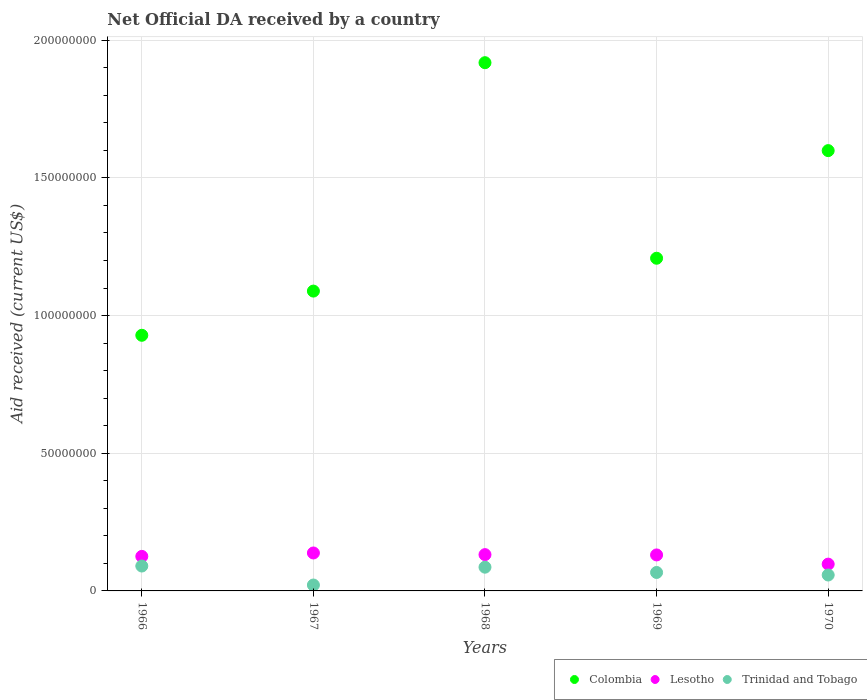What is the net official development assistance aid received in Trinidad and Tobago in 1968?
Your response must be concise. 8.62e+06. Across all years, what is the maximum net official development assistance aid received in Trinidad and Tobago?
Offer a terse response. 9.04e+06. Across all years, what is the minimum net official development assistance aid received in Lesotho?
Your answer should be compact. 9.73e+06. In which year was the net official development assistance aid received in Colombia maximum?
Give a very brief answer. 1968. What is the total net official development assistance aid received in Colombia in the graph?
Give a very brief answer. 6.74e+08. What is the difference between the net official development assistance aid received in Colombia in 1967 and that in 1968?
Give a very brief answer. -8.29e+07. What is the difference between the net official development assistance aid received in Trinidad and Tobago in 1969 and the net official development assistance aid received in Lesotho in 1970?
Ensure brevity in your answer.  -3.03e+06. What is the average net official development assistance aid received in Trinidad and Tobago per year?
Give a very brief answer. 6.46e+06. In the year 1970, what is the difference between the net official development assistance aid received in Colombia and net official development assistance aid received in Lesotho?
Your answer should be very brief. 1.50e+08. What is the ratio of the net official development assistance aid received in Lesotho in 1966 to that in 1970?
Your answer should be compact. 1.29. Is the net official development assistance aid received in Trinidad and Tobago in 1967 less than that in 1970?
Provide a succinct answer. Yes. What is the difference between the highest and the second highest net official development assistance aid received in Trinidad and Tobago?
Ensure brevity in your answer.  4.20e+05. What is the difference between the highest and the lowest net official development assistance aid received in Lesotho?
Your answer should be compact. 4.05e+06. Is the sum of the net official development assistance aid received in Colombia in 1966 and 1970 greater than the maximum net official development assistance aid received in Lesotho across all years?
Give a very brief answer. Yes. Is the net official development assistance aid received in Trinidad and Tobago strictly greater than the net official development assistance aid received in Colombia over the years?
Give a very brief answer. No. How many years are there in the graph?
Give a very brief answer. 5. What is the difference between two consecutive major ticks on the Y-axis?
Your answer should be very brief. 5.00e+07. Does the graph contain any zero values?
Make the answer very short. No. Where does the legend appear in the graph?
Provide a succinct answer. Bottom right. How many legend labels are there?
Give a very brief answer. 3. What is the title of the graph?
Your response must be concise. Net Official DA received by a country. Does "Central Europe" appear as one of the legend labels in the graph?
Offer a very short reply. No. What is the label or title of the X-axis?
Ensure brevity in your answer.  Years. What is the label or title of the Y-axis?
Your answer should be very brief. Aid received (current US$). What is the Aid received (current US$) of Colombia in 1966?
Offer a terse response. 9.28e+07. What is the Aid received (current US$) of Lesotho in 1966?
Provide a short and direct response. 1.25e+07. What is the Aid received (current US$) of Trinidad and Tobago in 1966?
Offer a very short reply. 9.04e+06. What is the Aid received (current US$) of Colombia in 1967?
Your response must be concise. 1.09e+08. What is the Aid received (current US$) of Lesotho in 1967?
Provide a short and direct response. 1.38e+07. What is the Aid received (current US$) of Trinidad and Tobago in 1967?
Make the answer very short. 2.14e+06. What is the Aid received (current US$) of Colombia in 1968?
Ensure brevity in your answer.  1.92e+08. What is the Aid received (current US$) of Lesotho in 1968?
Make the answer very short. 1.32e+07. What is the Aid received (current US$) of Trinidad and Tobago in 1968?
Ensure brevity in your answer.  8.62e+06. What is the Aid received (current US$) in Colombia in 1969?
Make the answer very short. 1.21e+08. What is the Aid received (current US$) of Lesotho in 1969?
Provide a short and direct response. 1.31e+07. What is the Aid received (current US$) in Trinidad and Tobago in 1969?
Your response must be concise. 6.70e+06. What is the Aid received (current US$) in Colombia in 1970?
Your answer should be compact. 1.60e+08. What is the Aid received (current US$) of Lesotho in 1970?
Your answer should be compact. 9.73e+06. What is the Aid received (current US$) of Trinidad and Tobago in 1970?
Give a very brief answer. 5.78e+06. Across all years, what is the maximum Aid received (current US$) of Colombia?
Your response must be concise. 1.92e+08. Across all years, what is the maximum Aid received (current US$) of Lesotho?
Your response must be concise. 1.38e+07. Across all years, what is the maximum Aid received (current US$) of Trinidad and Tobago?
Ensure brevity in your answer.  9.04e+06. Across all years, what is the minimum Aid received (current US$) of Colombia?
Make the answer very short. 9.28e+07. Across all years, what is the minimum Aid received (current US$) in Lesotho?
Offer a terse response. 9.73e+06. Across all years, what is the minimum Aid received (current US$) of Trinidad and Tobago?
Make the answer very short. 2.14e+06. What is the total Aid received (current US$) of Colombia in the graph?
Offer a terse response. 6.74e+08. What is the total Aid received (current US$) in Lesotho in the graph?
Keep it short and to the point. 6.23e+07. What is the total Aid received (current US$) of Trinidad and Tobago in the graph?
Offer a very short reply. 3.23e+07. What is the difference between the Aid received (current US$) in Colombia in 1966 and that in 1967?
Ensure brevity in your answer.  -1.60e+07. What is the difference between the Aid received (current US$) in Lesotho in 1966 and that in 1967?
Ensure brevity in your answer.  -1.24e+06. What is the difference between the Aid received (current US$) in Trinidad and Tobago in 1966 and that in 1967?
Offer a terse response. 6.90e+06. What is the difference between the Aid received (current US$) in Colombia in 1966 and that in 1968?
Ensure brevity in your answer.  -9.90e+07. What is the difference between the Aid received (current US$) of Lesotho in 1966 and that in 1968?
Keep it short and to the point. -6.40e+05. What is the difference between the Aid received (current US$) of Colombia in 1966 and that in 1969?
Give a very brief answer. -2.80e+07. What is the difference between the Aid received (current US$) in Lesotho in 1966 and that in 1969?
Your answer should be compact. -5.30e+05. What is the difference between the Aid received (current US$) of Trinidad and Tobago in 1966 and that in 1969?
Offer a very short reply. 2.34e+06. What is the difference between the Aid received (current US$) in Colombia in 1966 and that in 1970?
Provide a succinct answer. -6.71e+07. What is the difference between the Aid received (current US$) of Lesotho in 1966 and that in 1970?
Offer a very short reply. 2.81e+06. What is the difference between the Aid received (current US$) in Trinidad and Tobago in 1966 and that in 1970?
Keep it short and to the point. 3.26e+06. What is the difference between the Aid received (current US$) of Colombia in 1967 and that in 1968?
Offer a terse response. -8.29e+07. What is the difference between the Aid received (current US$) of Trinidad and Tobago in 1967 and that in 1968?
Give a very brief answer. -6.48e+06. What is the difference between the Aid received (current US$) of Colombia in 1967 and that in 1969?
Ensure brevity in your answer.  -1.19e+07. What is the difference between the Aid received (current US$) in Lesotho in 1967 and that in 1969?
Your answer should be very brief. 7.10e+05. What is the difference between the Aid received (current US$) of Trinidad and Tobago in 1967 and that in 1969?
Provide a short and direct response. -4.56e+06. What is the difference between the Aid received (current US$) in Colombia in 1967 and that in 1970?
Provide a succinct answer. -5.10e+07. What is the difference between the Aid received (current US$) of Lesotho in 1967 and that in 1970?
Give a very brief answer. 4.05e+06. What is the difference between the Aid received (current US$) of Trinidad and Tobago in 1967 and that in 1970?
Your answer should be very brief. -3.64e+06. What is the difference between the Aid received (current US$) in Colombia in 1968 and that in 1969?
Provide a succinct answer. 7.10e+07. What is the difference between the Aid received (current US$) in Trinidad and Tobago in 1968 and that in 1969?
Give a very brief answer. 1.92e+06. What is the difference between the Aid received (current US$) in Colombia in 1968 and that in 1970?
Ensure brevity in your answer.  3.19e+07. What is the difference between the Aid received (current US$) of Lesotho in 1968 and that in 1970?
Keep it short and to the point. 3.45e+06. What is the difference between the Aid received (current US$) in Trinidad and Tobago in 1968 and that in 1970?
Your response must be concise. 2.84e+06. What is the difference between the Aid received (current US$) of Colombia in 1969 and that in 1970?
Your answer should be very brief. -3.91e+07. What is the difference between the Aid received (current US$) in Lesotho in 1969 and that in 1970?
Make the answer very short. 3.34e+06. What is the difference between the Aid received (current US$) in Trinidad and Tobago in 1969 and that in 1970?
Give a very brief answer. 9.20e+05. What is the difference between the Aid received (current US$) of Colombia in 1966 and the Aid received (current US$) of Lesotho in 1967?
Keep it short and to the point. 7.90e+07. What is the difference between the Aid received (current US$) in Colombia in 1966 and the Aid received (current US$) in Trinidad and Tobago in 1967?
Provide a short and direct response. 9.07e+07. What is the difference between the Aid received (current US$) of Lesotho in 1966 and the Aid received (current US$) of Trinidad and Tobago in 1967?
Offer a very short reply. 1.04e+07. What is the difference between the Aid received (current US$) of Colombia in 1966 and the Aid received (current US$) of Lesotho in 1968?
Give a very brief answer. 7.96e+07. What is the difference between the Aid received (current US$) in Colombia in 1966 and the Aid received (current US$) in Trinidad and Tobago in 1968?
Ensure brevity in your answer.  8.42e+07. What is the difference between the Aid received (current US$) in Lesotho in 1966 and the Aid received (current US$) in Trinidad and Tobago in 1968?
Your answer should be very brief. 3.92e+06. What is the difference between the Aid received (current US$) in Colombia in 1966 and the Aid received (current US$) in Lesotho in 1969?
Offer a terse response. 7.98e+07. What is the difference between the Aid received (current US$) in Colombia in 1966 and the Aid received (current US$) in Trinidad and Tobago in 1969?
Your response must be concise. 8.61e+07. What is the difference between the Aid received (current US$) of Lesotho in 1966 and the Aid received (current US$) of Trinidad and Tobago in 1969?
Keep it short and to the point. 5.84e+06. What is the difference between the Aid received (current US$) of Colombia in 1966 and the Aid received (current US$) of Lesotho in 1970?
Provide a succinct answer. 8.31e+07. What is the difference between the Aid received (current US$) of Colombia in 1966 and the Aid received (current US$) of Trinidad and Tobago in 1970?
Offer a very short reply. 8.70e+07. What is the difference between the Aid received (current US$) in Lesotho in 1966 and the Aid received (current US$) in Trinidad and Tobago in 1970?
Your answer should be very brief. 6.76e+06. What is the difference between the Aid received (current US$) of Colombia in 1967 and the Aid received (current US$) of Lesotho in 1968?
Provide a succinct answer. 9.57e+07. What is the difference between the Aid received (current US$) of Colombia in 1967 and the Aid received (current US$) of Trinidad and Tobago in 1968?
Ensure brevity in your answer.  1.00e+08. What is the difference between the Aid received (current US$) of Lesotho in 1967 and the Aid received (current US$) of Trinidad and Tobago in 1968?
Provide a short and direct response. 5.16e+06. What is the difference between the Aid received (current US$) in Colombia in 1967 and the Aid received (current US$) in Lesotho in 1969?
Ensure brevity in your answer.  9.58e+07. What is the difference between the Aid received (current US$) of Colombia in 1967 and the Aid received (current US$) of Trinidad and Tobago in 1969?
Your answer should be very brief. 1.02e+08. What is the difference between the Aid received (current US$) in Lesotho in 1967 and the Aid received (current US$) in Trinidad and Tobago in 1969?
Provide a short and direct response. 7.08e+06. What is the difference between the Aid received (current US$) of Colombia in 1967 and the Aid received (current US$) of Lesotho in 1970?
Make the answer very short. 9.92e+07. What is the difference between the Aid received (current US$) in Colombia in 1967 and the Aid received (current US$) in Trinidad and Tobago in 1970?
Keep it short and to the point. 1.03e+08. What is the difference between the Aid received (current US$) in Lesotho in 1967 and the Aid received (current US$) in Trinidad and Tobago in 1970?
Provide a short and direct response. 8.00e+06. What is the difference between the Aid received (current US$) of Colombia in 1968 and the Aid received (current US$) of Lesotho in 1969?
Ensure brevity in your answer.  1.79e+08. What is the difference between the Aid received (current US$) of Colombia in 1968 and the Aid received (current US$) of Trinidad and Tobago in 1969?
Offer a terse response. 1.85e+08. What is the difference between the Aid received (current US$) of Lesotho in 1968 and the Aid received (current US$) of Trinidad and Tobago in 1969?
Your answer should be very brief. 6.48e+06. What is the difference between the Aid received (current US$) of Colombia in 1968 and the Aid received (current US$) of Lesotho in 1970?
Offer a terse response. 1.82e+08. What is the difference between the Aid received (current US$) of Colombia in 1968 and the Aid received (current US$) of Trinidad and Tobago in 1970?
Give a very brief answer. 1.86e+08. What is the difference between the Aid received (current US$) in Lesotho in 1968 and the Aid received (current US$) in Trinidad and Tobago in 1970?
Keep it short and to the point. 7.40e+06. What is the difference between the Aid received (current US$) in Colombia in 1969 and the Aid received (current US$) in Lesotho in 1970?
Your response must be concise. 1.11e+08. What is the difference between the Aid received (current US$) in Colombia in 1969 and the Aid received (current US$) in Trinidad and Tobago in 1970?
Offer a terse response. 1.15e+08. What is the difference between the Aid received (current US$) of Lesotho in 1969 and the Aid received (current US$) of Trinidad and Tobago in 1970?
Your response must be concise. 7.29e+06. What is the average Aid received (current US$) in Colombia per year?
Provide a short and direct response. 1.35e+08. What is the average Aid received (current US$) in Lesotho per year?
Provide a succinct answer. 1.25e+07. What is the average Aid received (current US$) of Trinidad and Tobago per year?
Your answer should be very brief. 6.46e+06. In the year 1966, what is the difference between the Aid received (current US$) of Colombia and Aid received (current US$) of Lesotho?
Provide a short and direct response. 8.03e+07. In the year 1966, what is the difference between the Aid received (current US$) of Colombia and Aid received (current US$) of Trinidad and Tobago?
Offer a terse response. 8.38e+07. In the year 1966, what is the difference between the Aid received (current US$) of Lesotho and Aid received (current US$) of Trinidad and Tobago?
Provide a succinct answer. 3.50e+06. In the year 1967, what is the difference between the Aid received (current US$) of Colombia and Aid received (current US$) of Lesotho?
Give a very brief answer. 9.51e+07. In the year 1967, what is the difference between the Aid received (current US$) of Colombia and Aid received (current US$) of Trinidad and Tobago?
Make the answer very short. 1.07e+08. In the year 1967, what is the difference between the Aid received (current US$) in Lesotho and Aid received (current US$) in Trinidad and Tobago?
Your response must be concise. 1.16e+07. In the year 1968, what is the difference between the Aid received (current US$) in Colombia and Aid received (current US$) in Lesotho?
Your response must be concise. 1.79e+08. In the year 1968, what is the difference between the Aid received (current US$) of Colombia and Aid received (current US$) of Trinidad and Tobago?
Ensure brevity in your answer.  1.83e+08. In the year 1968, what is the difference between the Aid received (current US$) in Lesotho and Aid received (current US$) in Trinidad and Tobago?
Ensure brevity in your answer.  4.56e+06. In the year 1969, what is the difference between the Aid received (current US$) of Colombia and Aid received (current US$) of Lesotho?
Keep it short and to the point. 1.08e+08. In the year 1969, what is the difference between the Aid received (current US$) in Colombia and Aid received (current US$) in Trinidad and Tobago?
Make the answer very short. 1.14e+08. In the year 1969, what is the difference between the Aid received (current US$) in Lesotho and Aid received (current US$) in Trinidad and Tobago?
Give a very brief answer. 6.37e+06. In the year 1970, what is the difference between the Aid received (current US$) of Colombia and Aid received (current US$) of Lesotho?
Ensure brevity in your answer.  1.50e+08. In the year 1970, what is the difference between the Aid received (current US$) of Colombia and Aid received (current US$) of Trinidad and Tobago?
Provide a short and direct response. 1.54e+08. In the year 1970, what is the difference between the Aid received (current US$) of Lesotho and Aid received (current US$) of Trinidad and Tobago?
Make the answer very short. 3.95e+06. What is the ratio of the Aid received (current US$) in Colombia in 1966 to that in 1967?
Provide a succinct answer. 0.85. What is the ratio of the Aid received (current US$) of Lesotho in 1966 to that in 1967?
Provide a short and direct response. 0.91. What is the ratio of the Aid received (current US$) in Trinidad and Tobago in 1966 to that in 1967?
Give a very brief answer. 4.22. What is the ratio of the Aid received (current US$) of Colombia in 1966 to that in 1968?
Offer a very short reply. 0.48. What is the ratio of the Aid received (current US$) in Lesotho in 1966 to that in 1968?
Make the answer very short. 0.95. What is the ratio of the Aid received (current US$) of Trinidad and Tobago in 1966 to that in 1968?
Ensure brevity in your answer.  1.05. What is the ratio of the Aid received (current US$) in Colombia in 1966 to that in 1969?
Provide a short and direct response. 0.77. What is the ratio of the Aid received (current US$) of Lesotho in 1966 to that in 1969?
Your answer should be compact. 0.96. What is the ratio of the Aid received (current US$) in Trinidad and Tobago in 1966 to that in 1969?
Give a very brief answer. 1.35. What is the ratio of the Aid received (current US$) of Colombia in 1966 to that in 1970?
Offer a very short reply. 0.58. What is the ratio of the Aid received (current US$) in Lesotho in 1966 to that in 1970?
Keep it short and to the point. 1.29. What is the ratio of the Aid received (current US$) of Trinidad and Tobago in 1966 to that in 1970?
Offer a very short reply. 1.56. What is the ratio of the Aid received (current US$) in Colombia in 1967 to that in 1968?
Ensure brevity in your answer.  0.57. What is the ratio of the Aid received (current US$) of Lesotho in 1967 to that in 1968?
Ensure brevity in your answer.  1.05. What is the ratio of the Aid received (current US$) of Trinidad and Tobago in 1967 to that in 1968?
Your answer should be very brief. 0.25. What is the ratio of the Aid received (current US$) of Colombia in 1967 to that in 1969?
Your answer should be compact. 0.9. What is the ratio of the Aid received (current US$) of Lesotho in 1967 to that in 1969?
Give a very brief answer. 1.05. What is the ratio of the Aid received (current US$) of Trinidad and Tobago in 1967 to that in 1969?
Give a very brief answer. 0.32. What is the ratio of the Aid received (current US$) in Colombia in 1967 to that in 1970?
Offer a very short reply. 0.68. What is the ratio of the Aid received (current US$) in Lesotho in 1967 to that in 1970?
Your answer should be compact. 1.42. What is the ratio of the Aid received (current US$) of Trinidad and Tobago in 1967 to that in 1970?
Provide a short and direct response. 0.37. What is the ratio of the Aid received (current US$) in Colombia in 1968 to that in 1969?
Your answer should be compact. 1.59. What is the ratio of the Aid received (current US$) in Lesotho in 1968 to that in 1969?
Your answer should be very brief. 1.01. What is the ratio of the Aid received (current US$) in Trinidad and Tobago in 1968 to that in 1969?
Give a very brief answer. 1.29. What is the ratio of the Aid received (current US$) in Colombia in 1968 to that in 1970?
Give a very brief answer. 1.2. What is the ratio of the Aid received (current US$) in Lesotho in 1968 to that in 1970?
Your answer should be very brief. 1.35. What is the ratio of the Aid received (current US$) in Trinidad and Tobago in 1968 to that in 1970?
Make the answer very short. 1.49. What is the ratio of the Aid received (current US$) in Colombia in 1969 to that in 1970?
Provide a succinct answer. 0.76. What is the ratio of the Aid received (current US$) of Lesotho in 1969 to that in 1970?
Offer a very short reply. 1.34. What is the ratio of the Aid received (current US$) in Trinidad and Tobago in 1969 to that in 1970?
Provide a succinct answer. 1.16. What is the difference between the highest and the second highest Aid received (current US$) of Colombia?
Offer a very short reply. 3.19e+07. What is the difference between the highest and the lowest Aid received (current US$) in Colombia?
Your answer should be very brief. 9.90e+07. What is the difference between the highest and the lowest Aid received (current US$) of Lesotho?
Make the answer very short. 4.05e+06. What is the difference between the highest and the lowest Aid received (current US$) of Trinidad and Tobago?
Provide a short and direct response. 6.90e+06. 